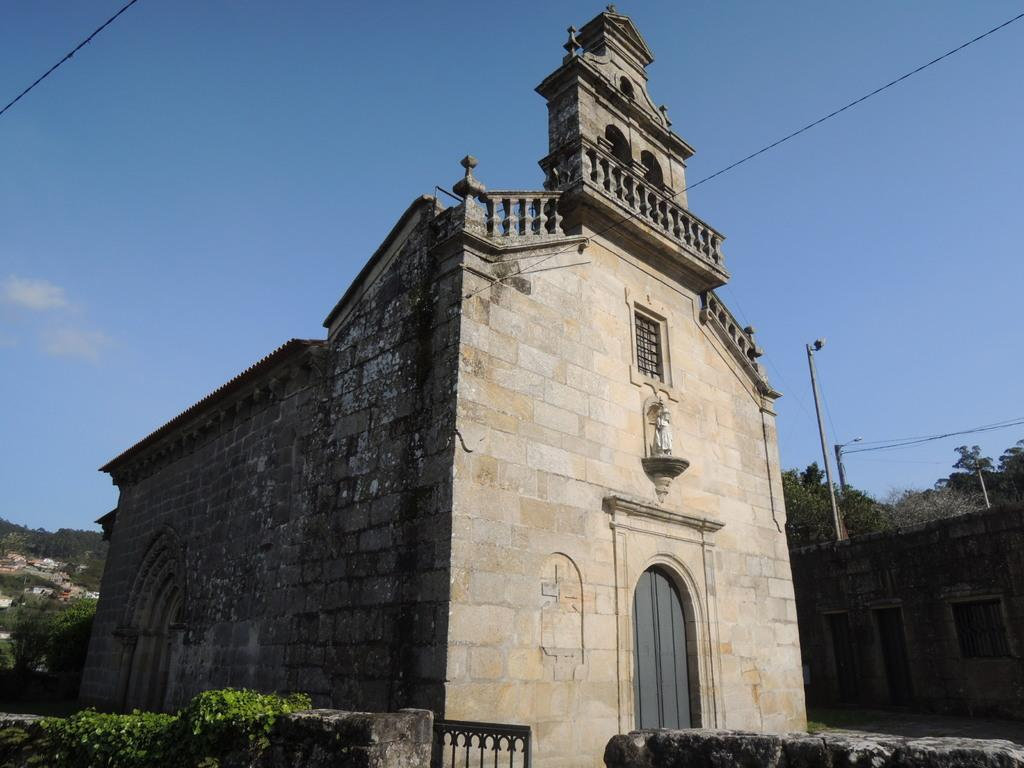What type of structure is present in the image? There is a building in the image. What is located near the building? There is a wall with a metal gate in the image. What other objects can be seen in the image? There are poles and trees visible in the image. How would you describe the weather in the image? The sky is cloudy in the image. What type of joke is being told by the trees in the image? There are no jokes being told in the image, as the trees are not capable of speech or humor. 